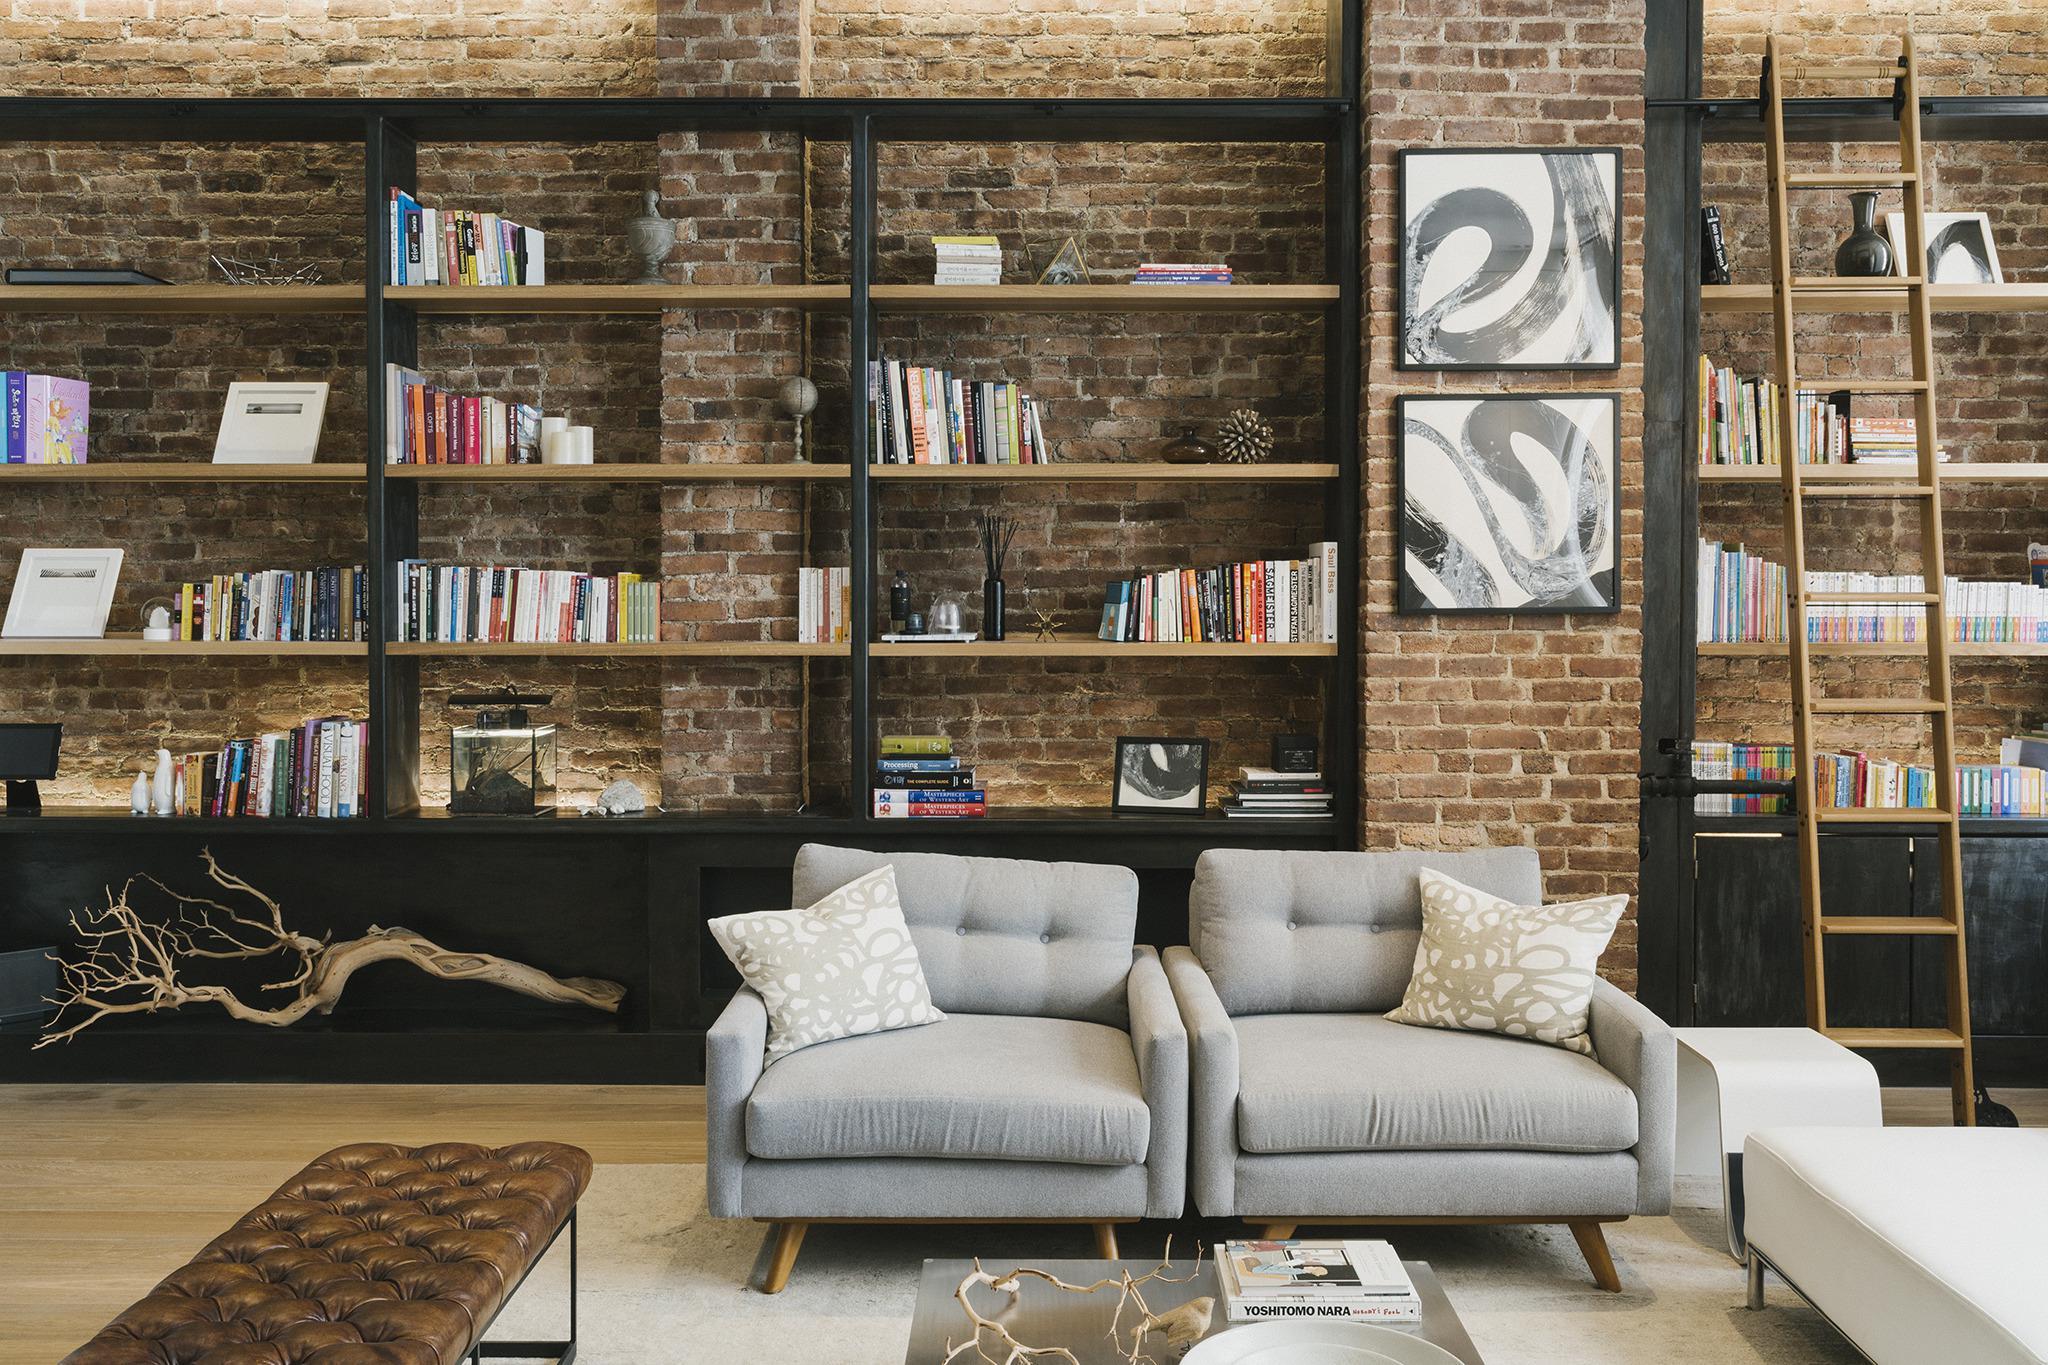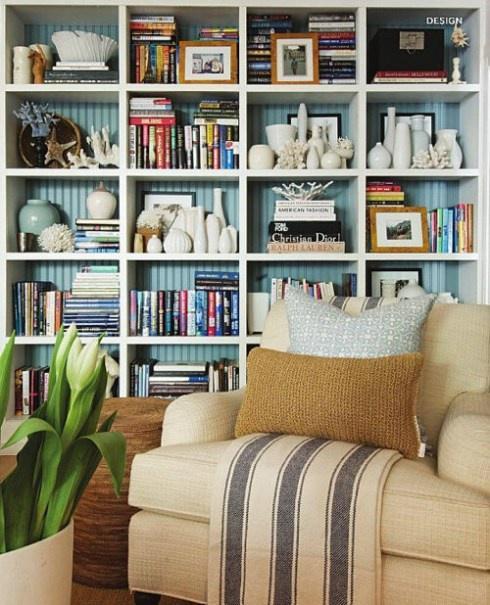The first image is the image on the left, the second image is the image on the right. For the images displayed, is the sentence "In the left image there is a ladder leaning against the bookcase." factually correct? Answer yes or no. Yes. The first image is the image on the left, the second image is the image on the right. For the images shown, is this caption "One image includes a ladder leaning on a wall of bookshelves in a room with a wood floor and a pale rug." true? Answer yes or no. Yes. 